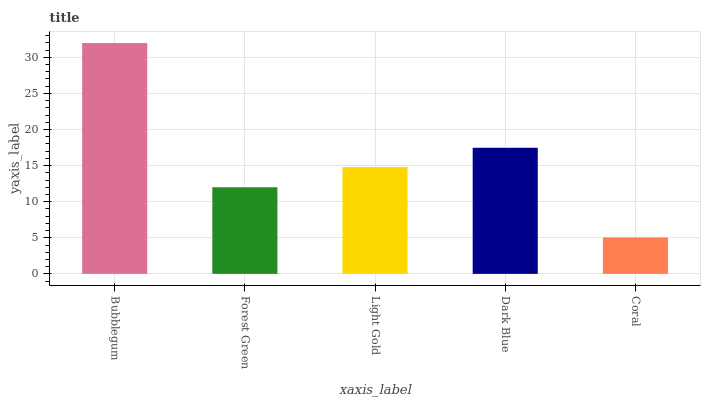Is Coral the minimum?
Answer yes or no. Yes. Is Bubblegum the maximum?
Answer yes or no. Yes. Is Forest Green the minimum?
Answer yes or no. No. Is Forest Green the maximum?
Answer yes or no. No. Is Bubblegum greater than Forest Green?
Answer yes or no. Yes. Is Forest Green less than Bubblegum?
Answer yes or no. Yes. Is Forest Green greater than Bubblegum?
Answer yes or no. No. Is Bubblegum less than Forest Green?
Answer yes or no. No. Is Light Gold the high median?
Answer yes or no. Yes. Is Light Gold the low median?
Answer yes or no. Yes. Is Forest Green the high median?
Answer yes or no. No. Is Forest Green the low median?
Answer yes or no. No. 